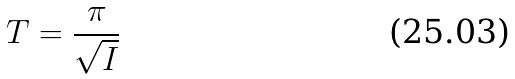Convert formula to latex. <formula><loc_0><loc_0><loc_500><loc_500>T = \frac { \pi } { \sqrt { I } }</formula> 